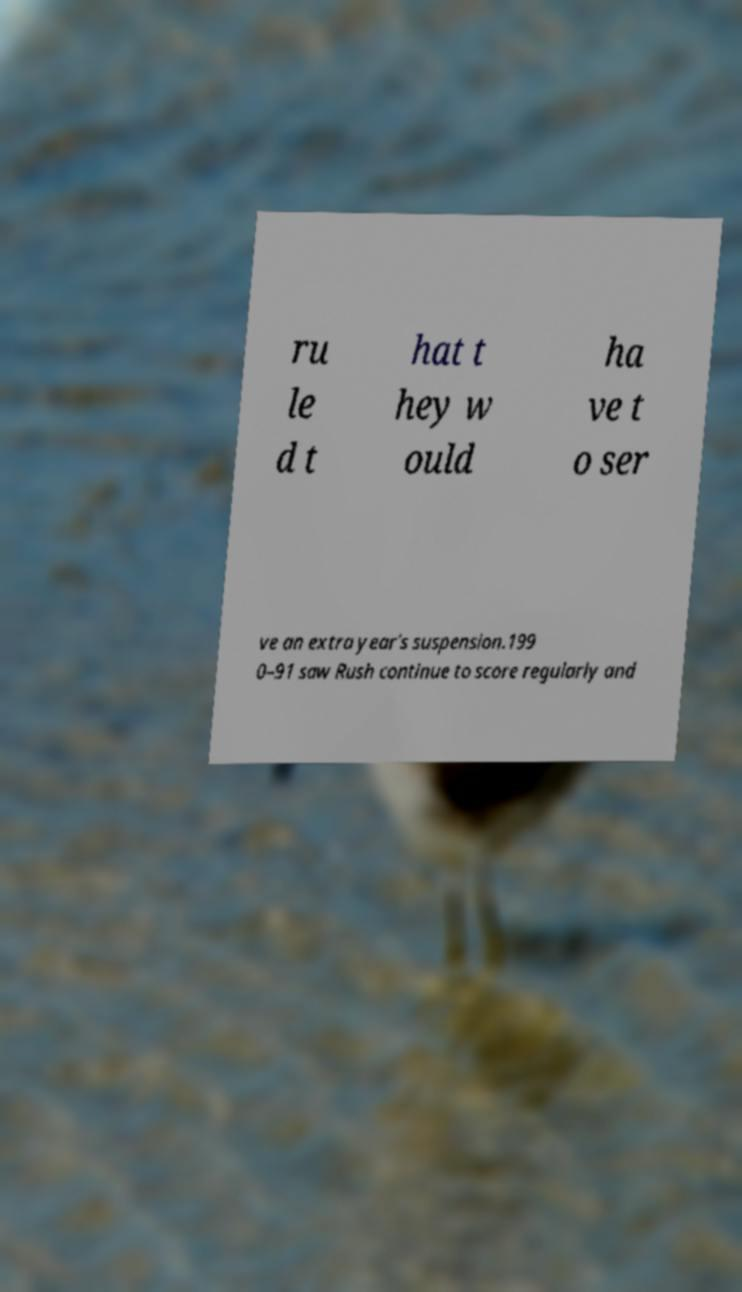Can you accurately transcribe the text from the provided image for me? ru le d t hat t hey w ould ha ve t o ser ve an extra year's suspension.199 0–91 saw Rush continue to score regularly and 